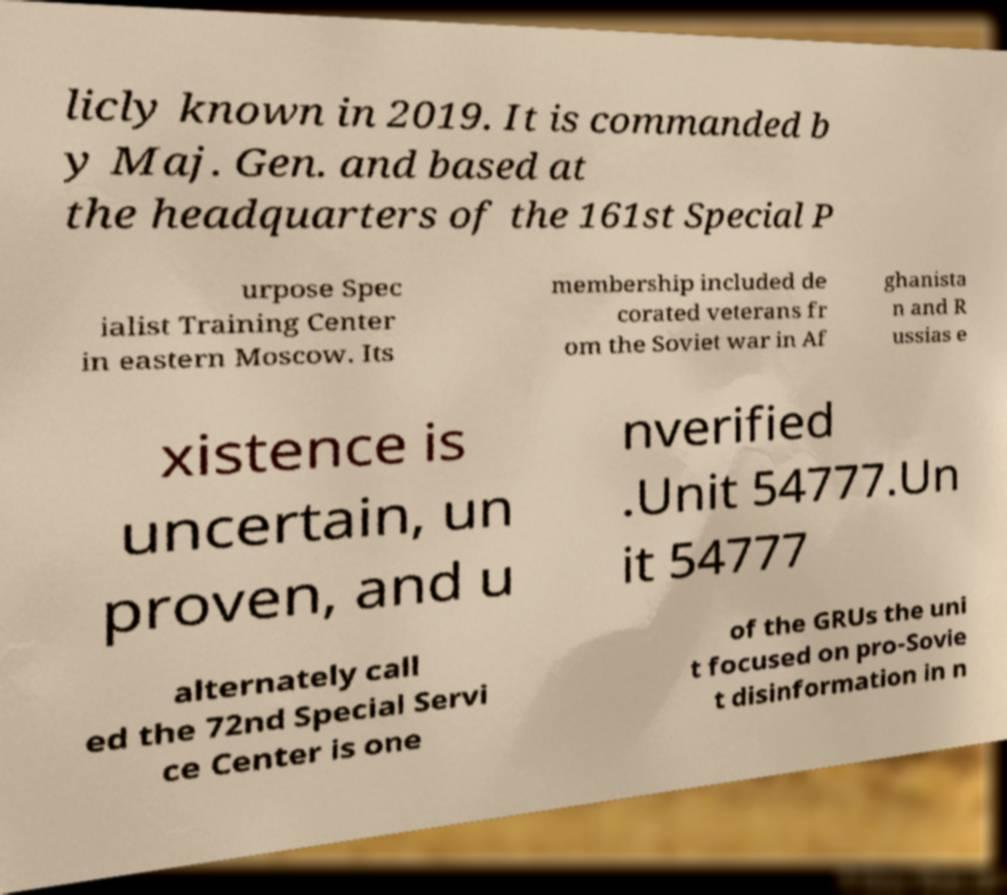Please identify and transcribe the text found in this image. licly known in 2019. It is commanded b y Maj. Gen. and based at the headquarters of the 161st Special P urpose Spec ialist Training Center in eastern Moscow. Its membership included de corated veterans fr om the Soviet war in Af ghanista n and R ussias e xistence is uncertain, un proven, and u nverified .Unit 54777.Un it 54777 alternately call ed the 72nd Special Servi ce Center is one of the GRUs the uni t focused on pro-Sovie t disinformation in n 